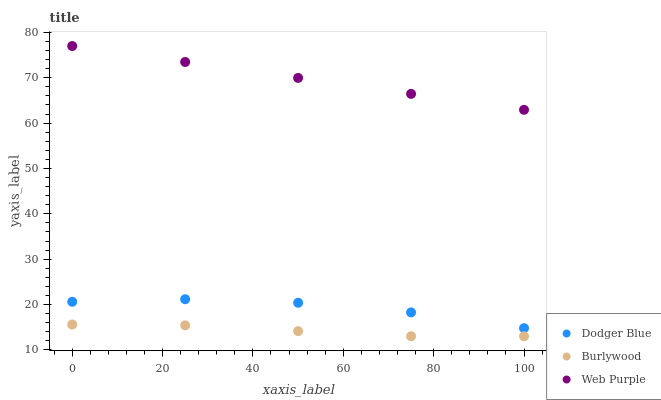Does Burlywood have the minimum area under the curve?
Answer yes or no. Yes. Does Web Purple have the maximum area under the curve?
Answer yes or no. Yes. Does Dodger Blue have the minimum area under the curve?
Answer yes or no. No. Does Dodger Blue have the maximum area under the curve?
Answer yes or no. No. Is Web Purple the smoothest?
Answer yes or no. Yes. Is Dodger Blue the roughest?
Answer yes or no. Yes. Is Dodger Blue the smoothest?
Answer yes or no. No. Is Web Purple the roughest?
Answer yes or no. No. Does Burlywood have the lowest value?
Answer yes or no. Yes. Does Dodger Blue have the lowest value?
Answer yes or no. No. Does Web Purple have the highest value?
Answer yes or no. Yes. Does Dodger Blue have the highest value?
Answer yes or no. No. Is Burlywood less than Dodger Blue?
Answer yes or no. Yes. Is Web Purple greater than Burlywood?
Answer yes or no. Yes. Does Burlywood intersect Dodger Blue?
Answer yes or no. No. 